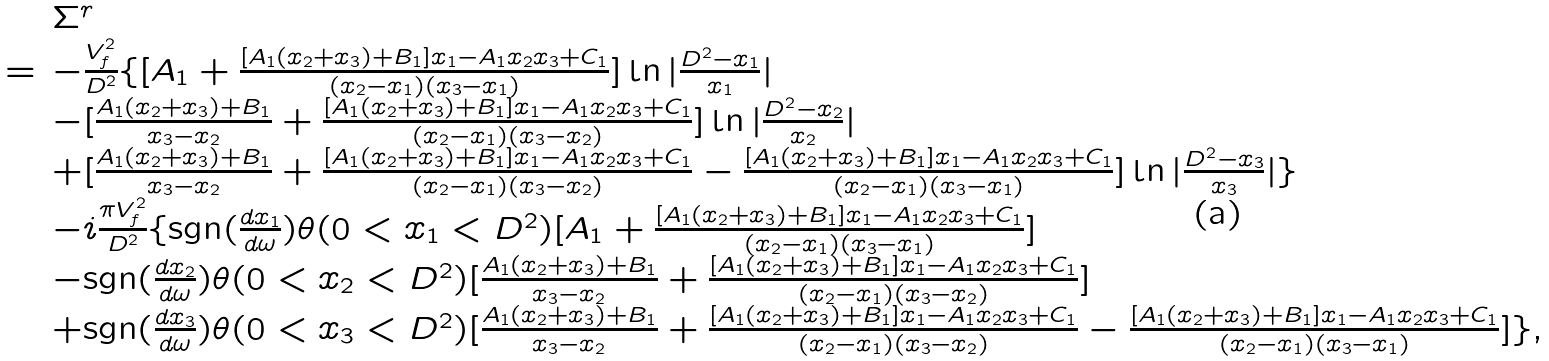<formula> <loc_0><loc_0><loc_500><loc_500>\begin{array} { c l l } & & \Sigma ^ { r } \\ & = & - \frac { V _ { f } ^ { 2 } } { D ^ { 2 } } \{ [ A _ { 1 } + \frac { [ A _ { 1 } ( x _ { 2 } + x _ { 3 } ) + B _ { 1 } ] x _ { 1 } - A _ { 1 } x _ { 2 } x _ { 3 } + C _ { 1 } } { ( x _ { 2 } - x _ { 1 } ) ( x _ { 3 } - x _ { 1 } ) } ] \ln | \frac { D ^ { 2 } - x _ { 1 } } { x _ { 1 } } | \\ & & - [ \frac { A _ { 1 } ( x _ { 2 } + x _ { 3 } ) + B _ { 1 } } { x _ { 3 } - x _ { 2 } } + \frac { [ A _ { 1 } ( x _ { 2 } + x _ { 3 } ) + B _ { 1 } ] x _ { 1 } - A _ { 1 } x _ { 2 } x _ { 3 } + C _ { 1 } } { ( x _ { 2 } - x _ { 1 } ) ( x _ { 3 } - x _ { 2 } ) } ] \ln | \frac { D ^ { 2 } - x _ { 2 } } { x _ { 2 } } | \\ & & + [ \frac { A _ { 1 } ( x _ { 2 } + x _ { 3 } ) + B _ { 1 } } { x _ { 3 } - x _ { 2 } } + \frac { [ A _ { 1 } ( x _ { 2 } + x _ { 3 } ) + B _ { 1 } ] x _ { 1 } - A _ { 1 } x _ { 2 } x _ { 3 } + C _ { 1 } } { ( x _ { 2 } - x _ { 1 } ) ( x _ { 3 } - x _ { 2 } ) } - \frac { [ A _ { 1 } ( x _ { 2 } + x _ { 3 } ) + B _ { 1 } ] x _ { 1 } - A _ { 1 } x _ { 2 } x _ { 3 } + C _ { 1 } } { ( x _ { 2 } - x _ { 1 } ) ( x _ { 3 } - x _ { 1 } ) } ] \ln | \frac { D ^ { 2 } - x _ { 3 } } { x _ { 3 } } | \} \\ & & - i \frac { \pi V _ { f } ^ { 2 } } { D ^ { 2 } } \{ \text {sgn} ( \frac { d x _ { 1 } } { d \omega } ) \theta ( 0 < x _ { 1 } < D ^ { 2 } ) [ A _ { 1 } + \frac { [ A _ { 1 } ( x _ { 2 } + x _ { 3 } ) + B _ { 1 } ] x _ { 1 } - A _ { 1 } x _ { 2 } x _ { 3 } + C _ { 1 } } { ( x _ { 2 } - x _ { 1 } ) ( x _ { 3 } - x _ { 1 } ) } ] \\ & & - \text {sgn} ( \frac { d x _ { 2 } } { d \omega } ) \theta ( 0 < x _ { 2 } < D ^ { 2 } ) [ \frac { A _ { 1 } ( x _ { 2 } + x _ { 3 } ) + B _ { 1 } } { x _ { 3 } - x _ { 2 } } + \frac { [ A _ { 1 } ( x _ { 2 } + x _ { 3 } ) + B _ { 1 } ] x _ { 1 } - A _ { 1 } x _ { 2 } x _ { 3 } + C _ { 1 } } { ( x _ { 2 } - x _ { 1 } ) ( x _ { 3 } - x _ { 2 } ) } ] \\ & & + \text {sgn} ( \frac { d x _ { 3 } } { d \omega } ) \theta ( 0 < x _ { 3 } < D ^ { 2 } ) [ \frac { A _ { 1 } ( x _ { 2 } + x _ { 3 } ) + B _ { 1 } } { x _ { 3 } - x _ { 2 } } + \frac { [ A _ { 1 } ( x _ { 2 } + x _ { 3 } ) + B _ { 1 } ] x _ { 1 } - A _ { 1 } x _ { 2 } x _ { 3 } + C _ { 1 } } { ( x _ { 2 } - x _ { 1 } ) ( x _ { 3 } - x _ { 2 } ) } - \frac { [ A _ { 1 } ( x _ { 2 } + x _ { 3 } ) + B _ { 1 } ] x _ { 1 } - A _ { 1 } x _ { 2 } x _ { 3 } + C _ { 1 } } { ( x _ { 2 } - x _ { 1 } ) ( x _ { 3 } - x _ { 1 } ) } ] \} , \end{array}</formula> 